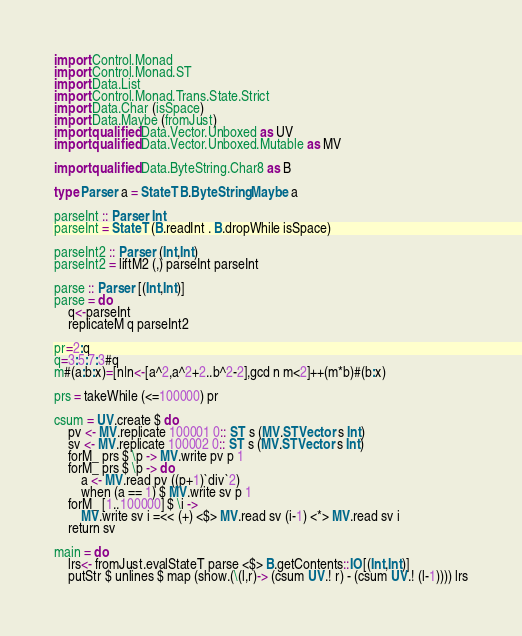Convert code to text. <code><loc_0><loc_0><loc_500><loc_500><_Haskell_>import Control.Monad
import Control.Monad.ST
import Data.List
import Control.Monad.Trans.State.Strict
import Data.Char (isSpace)
import Data.Maybe (fromJust)
import qualified Data.Vector.Unboxed as UV
import qualified Data.Vector.Unboxed.Mutable as MV

import qualified Data.ByteString.Char8 as B

type Parser a = StateT B.ByteString Maybe a

parseInt :: Parser Int
parseInt = StateT (B.readInt . B.dropWhile isSpace)

parseInt2 :: Parser (Int,Int)
parseInt2 = liftM2 (,) parseInt parseInt

parse :: Parser [(Int,Int)]
parse = do
    q<-parseInt
    replicateM q parseInt2

pr=2:q
q=3:5:7:3#q
m#(a:b:x)=[n|n<-[a^2,a^2+2..b^2-2],gcd n m<2]++(m*b)#(b:x)

prs = takeWhile (<=100000) pr

csum = UV.create $ do
    pv <- MV.replicate 100001 0:: ST s (MV.STVector s Int)
    sv <- MV.replicate 100002 0:: ST s (MV.STVector s Int)
    forM_ prs $ \p -> MV.write pv p 1
    forM_ prs $ \p -> do
        a <- MV.read pv ((p+1)`div`2)
        when (a == 1) $ MV.write sv p 1
    forM_ [1..100000] $ \i ->
        MV.write sv i =<< (+) <$> MV.read sv (i-1) <*> MV.read sv i
    return sv

main = do
    lrs<- fromJust.evalStateT parse <$> B.getContents::IO[(Int,Int)]
    putStr $ unlines $ map (show.(\(l,r)-> (csum UV.! r) - (csum UV.! (l-1)))) lrs
</code> 